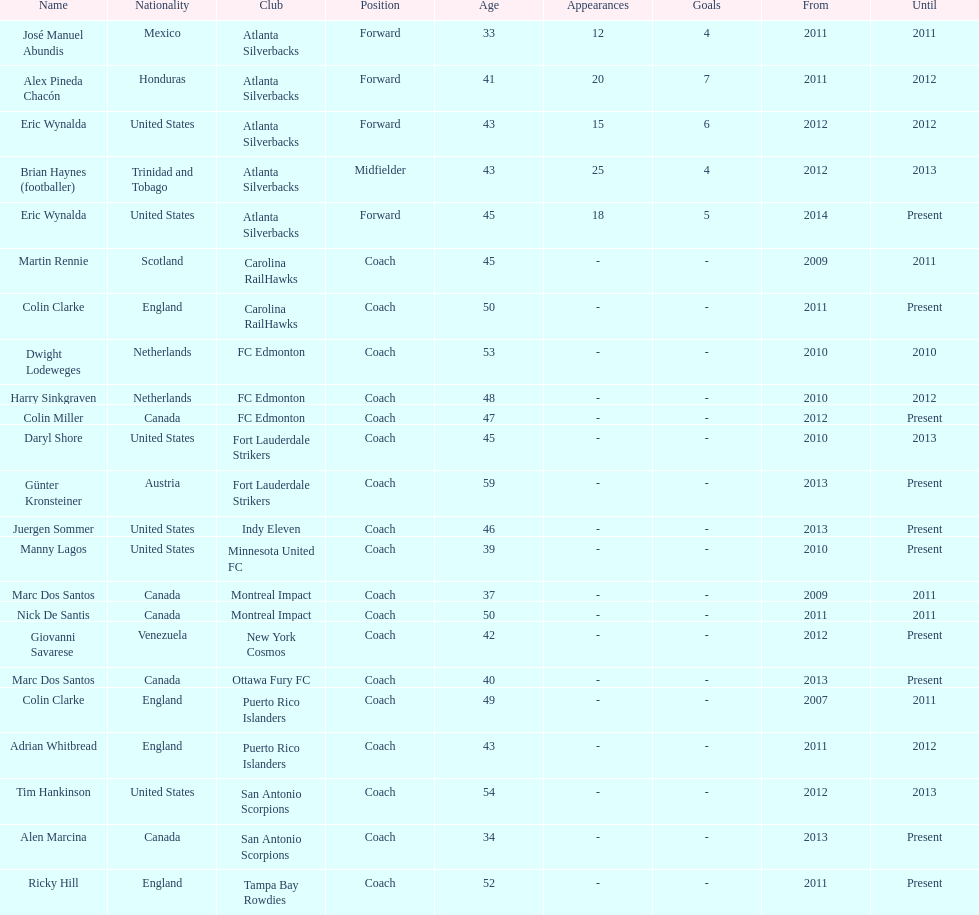What name is listed at the top? José Manuel Abundis. 